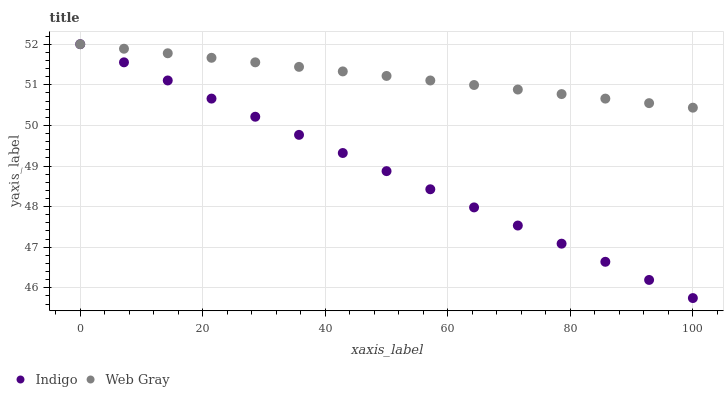Does Indigo have the minimum area under the curve?
Answer yes or no. Yes. Does Web Gray have the maximum area under the curve?
Answer yes or no. Yes. Does Indigo have the maximum area under the curve?
Answer yes or no. No. Is Web Gray the smoothest?
Answer yes or no. Yes. Is Indigo the roughest?
Answer yes or no. Yes. Is Indigo the smoothest?
Answer yes or no. No. Does Indigo have the lowest value?
Answer yes or no. Yes. Does Indigo have the highest value?
Answer yes or no. Yes. Does Indigo intersect Web Gray?
Answer yes or no. Yes. Is Indigo less than Web Gray?
Answer yes or no. No. Is Indigo greater than Web Gray?
Answer yes or no. No. 